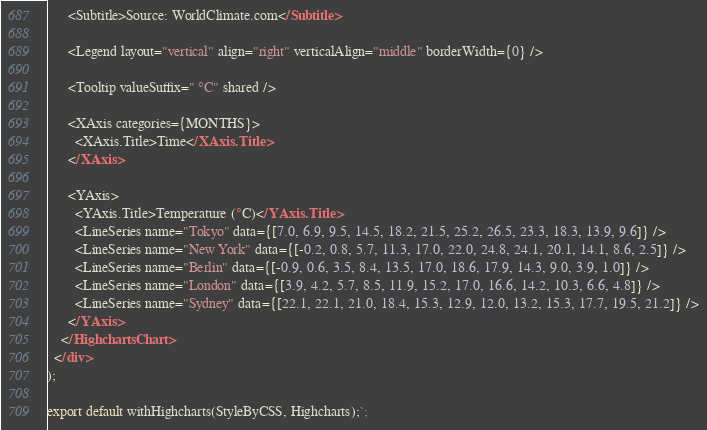<code> <loc_0><loc_0><loc_500><loc_500><_JavaScript_>
      <Subtitle>Source: WorldClimate.com</Subtitle>

      <Legend layout="vertical" align="right" verticalAlign="middle" borderWidth={0} />

      <Tooltip valueSuffix=" °C" shared />

      <XAxis categories={MONTHS}>
        <XAxis.Title>Time</XAxis.Title>
      </XAxis>

      <YAxis>
        <YAxis.Title>Temperature (°C)</YAxis.Title>
        <LineSeries name="Tokyo" data={[7.0, 6.9, 9.5, 14.5, 18.2, 21.5, 25.2, 26.5, 23.3, 18.3, 13.9, 9.6]} />
        <LineSeries name="New York" data={[-0.2, 0.8, 5.7, 11.3, 17.0, 22.0, 24.8, 24.1, 20.1, 14.1, 8.6, 2.5]} />
        <LineSeries name="Berlin" data={[-0.9, 0.6, 3.5, 8.4, 13.5, 17.0, 18.6, 17.9, 14.3, 9.0, 3.9, 1.0]} />
        <LineSeries name="London" data={[3.9, 4.2, 5.7, 8.5, 11.9, 15.2, 17.0, 16.6, 14.2, 10.3, 6.6, 4.8]} />
        <LineSeries name="Sydney" data={[22.1, 22.1, 21.0, 18.4, 15.3, 12.9, 12.0, 13.2, 15.3, 17.7, 19.5, 21.2]} />
      </YAxis>
    </HighchartsChart>
  </div>
);

export default withHighcharts(StyleByCSS, Highcharts);`;
</code> 